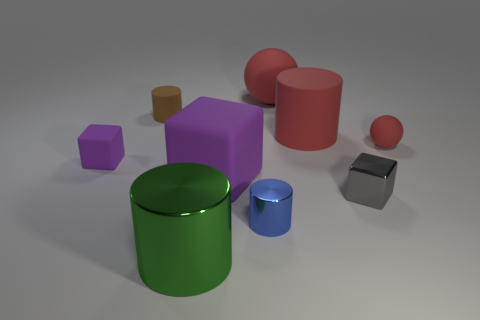What number of objects are either purple rubber blocks to the left of the large rubber cube or brown metal things?
Provide a short and direct response. 1. What number of big spheres are made of the same material as the big green cylinder?
Make the answer very short. 0. There is a large thing that is the same color as the large rubber sphere; what shape is it?
Offer a very short reply. Cylinder. Are there any shiny things of the same shape as the brown rubber thing?
Your response must be concise. Yes. What is the shape of the purple thing that is the same size as the green shiny thing?
Offer a terse response. Cube. There is a tiny rubber sphere; is it the same color as the rubber sphere left of the small gray cube?
Offer a very short reply. Yes. There is a rubber cylinder that is in front of the small brown cylinder; how many metal objects are left of it?
Offer a terse response. 2. There is a thing that is to the left of the big green cylinder and in front of the big red cylinder; how big is it?
Offer a very short reply. Small. Are there any blue matte cylinders that have the same size as the gray metallic thing?
Offer a terse response. No. Is the number of cylinders that are behind the large red matte cylinder greater than the number of big purple rubber blocks to the right of the tiny blue cylinder?
Ensure brevity in your answer.  Yes. 